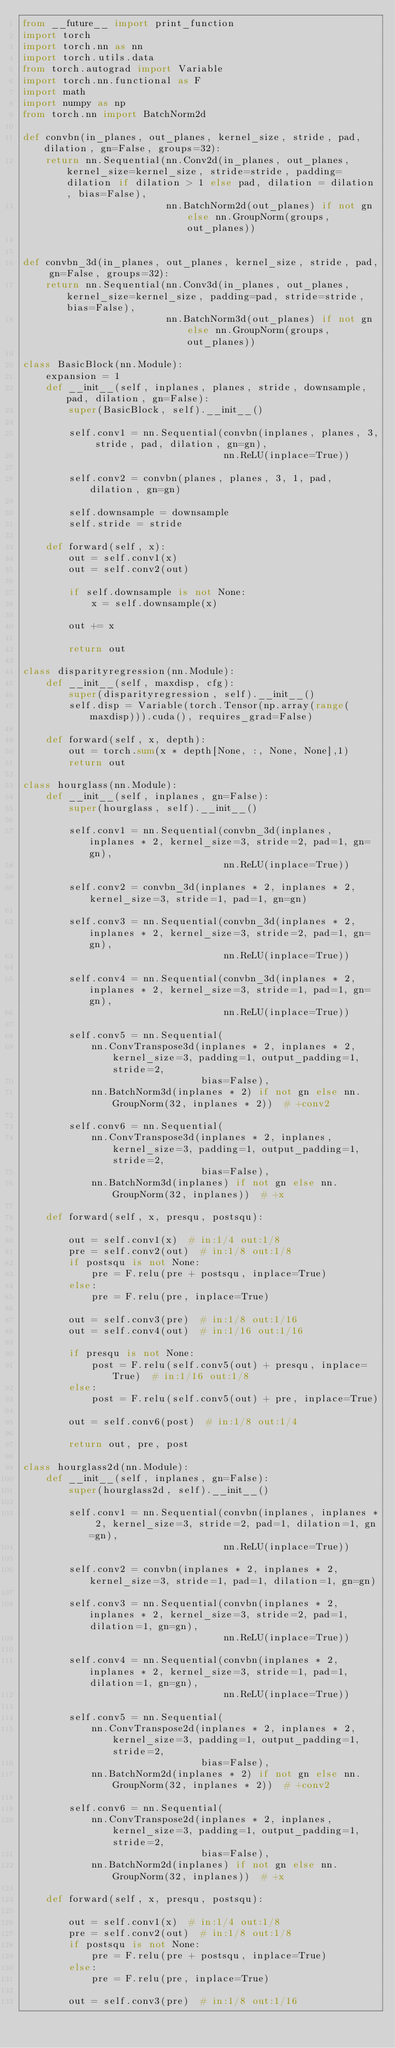Convert code to text. <code><loc_0><loc_0><loc_500><loc_500><_Python_>from __future__ import print_function
import torch
import torch.nn as nn
import torch.utils.data
from torch.autograd import Variable
import torch.nn.functional as F
import math
import numpy as np
from torch.nn import BatchNorm2d

def convbn(in_planes, out_planes, kernel_size, stride, pad, dilation, gn=False, groups=32):
    return nn.Sequential(nn.Conv2d(in_planes, out_planes, kernel_size=kernel_size, stride=stride, padding=dilation if dilation > 1 else pad, dilation = dilation, bias=False),
                         nn.BatchNorm2d(out_planes) if not gn else nn.GroupNorm(groups, out_planes))


def convbn_3d(in_planes, out_planes, kernel_size, stride, pad, gn=False, groups=32):
    return nn.Sequential(nn.Conv3d(in_planes, out_planes, kernel_size=kernel_size, padding=pad, stride=stride,bias=False),
                         nn.BatchNorm3d(out_planes) if not gn else nn.GroupNorm(groups, out_planes))

class BasicBlock(nn.Module):
    expansion = 1
    def __init__(self, inplanes, planes, stride, downsample, pad, dilation, gn=False):
        super(BasicBlock, self).__init__()

        self.conv1 = nn.Sequential(convbn(inplanes, planes, 3, stride, pad, dilation, gn=gn),
                                   nn.ReLU(inplace=True))

        self.conv2 = convbn(planes, planes, 3, 1, pad, dilation, gn=gn)

        self.downsample = downsample
        self.stride = stride

    def forward(self, x):
        out = self.conv1(x)
        out = self.conv2(out)

        if self.downsample is not None:
            x = self.downsample(x)

        out += x

        return out

class disparityregression(nn.Module):
    def __init__(self, maxdisp, cfg):
        super(disparityregression, self).__init__()
        self.disp = Variable(torch.Tensor(np.array(range(maxdisp))).cuda(), requires_grad=False)

    def forward(self, x, depth):
        out = torch.sum(x * depth[None, :, None, None],1)
        return out

class hourglass(nn.Module):
    def __init__(self, inplanes, gn=False):
        super(hourglass, self).__init__()

        self.conv1 = nn.Sequential(convbn_3d(inplanes, inplanes * 2, kernel_size=3, stride=2, pad=1, gn=gn),
                                   nn.ReLU(inplace=True))

        self.conv2 = convbn_3d(inplanes * 2, inplanes * 2, kernel_size=3, stride=1, pad=1, gn=gn)

        self.conv3 = nn.Sequential(convbn_3d(inplanes * 2, inplanes * 2, kernel_size=3, stride=2, pad=1, gn=gn),
                                   nn.ReLU(inplace=True))

        self.conv4 = nn.Sequential(convbn_3d(inplanes * 2, inplanes * 2, kernel_size=3, stride=1, pad=1, gn=gn),
                                   nn.ReLU(inplace=True))

        self.conv5 = nn.Sequential(
            nn.ConvTranspose3d(inplanes * 2, inplanes * 2, kernel_size=3, padding=1, output_padding=1, stride=2,
                               bias=False),
            nn.BatchNorm3d(inplanes * 2) if not gn else nn.GroupNorm(32, inplanes * 2))  # +conv2

        self.conv6 = nn.Sequential(
            nn.ConvTranspose3d(inplanes * 2, inplanes, kernel_size=3, padding=1, output_padding=1, stride=2,
                               bias=False),
            nn.BatchNorm3d(inplanes) if not gn else nn.GroupNorm(32, inplanes))  # +x

    def forward(self, x, presqu, postsqu):

        out = self.conv1(x)  # in:1/4 out:1/8
        pre = self.conv2(out)  # in:1/8 out:1/8
        if postsqu is not None:
            pre = F.relu(pre + postsqu, inplace=True)
        else:
            pre = F.relu(pre, inplace=True)

        out = self.conv3(pre)  # in:1/8 out:1/16
        out = self.conv4(out)  # in:1/16 out:1/16

        if presqu is not None:
            post = F.relu(self.conv5(out) + presqu, inplace=True)  # in:1/16 out:1/8
        else:
            post = F.relu(self.conv5(out) + pre, inplace=True)

        out = self.conv6(post)  # in:1/8 out:1/4

        return out, pre, post

class hourglass2d(nn.Module):
    def __init__(self, inplanes, gn=False):
        super(hourglass2d, self).__init__()

        self.conv1 = nn.Sequential(convbn(inplanes, inplanes * 2, kernel_size=3, stride=2, pad=1, dilation=1, gn=gn),
                                   nn.ReLU(inplace=True))

        self.conv2 = convbn(inplanes * 2, inplanes * 2, kernel_size=3, stride=1, pad=1, dilation=1, gn=gn)

        self.conv3 = nn.Sequential(convbn(inplanes * 2, inplanes * 2, kernel_size=3, stride=2, pad=1, dilation=1, gn=gn),
                                   nn.ReLU(inplace=True))

        self.conv4 = nn.Sequential(convbn(inplanes * 2, inplanes * 2, kernel_size=3, stride=1, pad=1, dilation=1, gn=gn),
                                   nn.ReLU(inplace=True))

        self.conv5 = nn.Sequential(
            nn.ConvTranspose2d(inplanes * 2, inplanes * 2, kernel_size=3, padding=1, output_padding=1, stride=2,
                               bias=False),
            nn.BatchNorm2d(inplanes * 2) if not gn else nn.GroupNorm(32, inplanes * 2))  # +conv2

        self.conv6 = nn.Sequential(
            nn.ConvTranspose2d(inplanes * 2, inplanes, kernel_size=3, padding=1, output_padding=1, stride=2,
                               bias=False),
            nn.BatchNorm2d(inplanes) if not gn else nn.GroupNorm(32, inplanes))  # +x

    def forward(self, x, presqu, postsqu):

        out = self.conv1(x)  # in:1/4 out:1/8
        pre = self.conv2(out)  # in:1/8 out:1/8
        if postsqu is not None:
            pre = F.relu(pre + postsqu, inplace=True)
        else:
            pre = F.relu(pre, inplace=True)

        out = self.conv3(pre)  # in:1/8 out:1/16</code> 